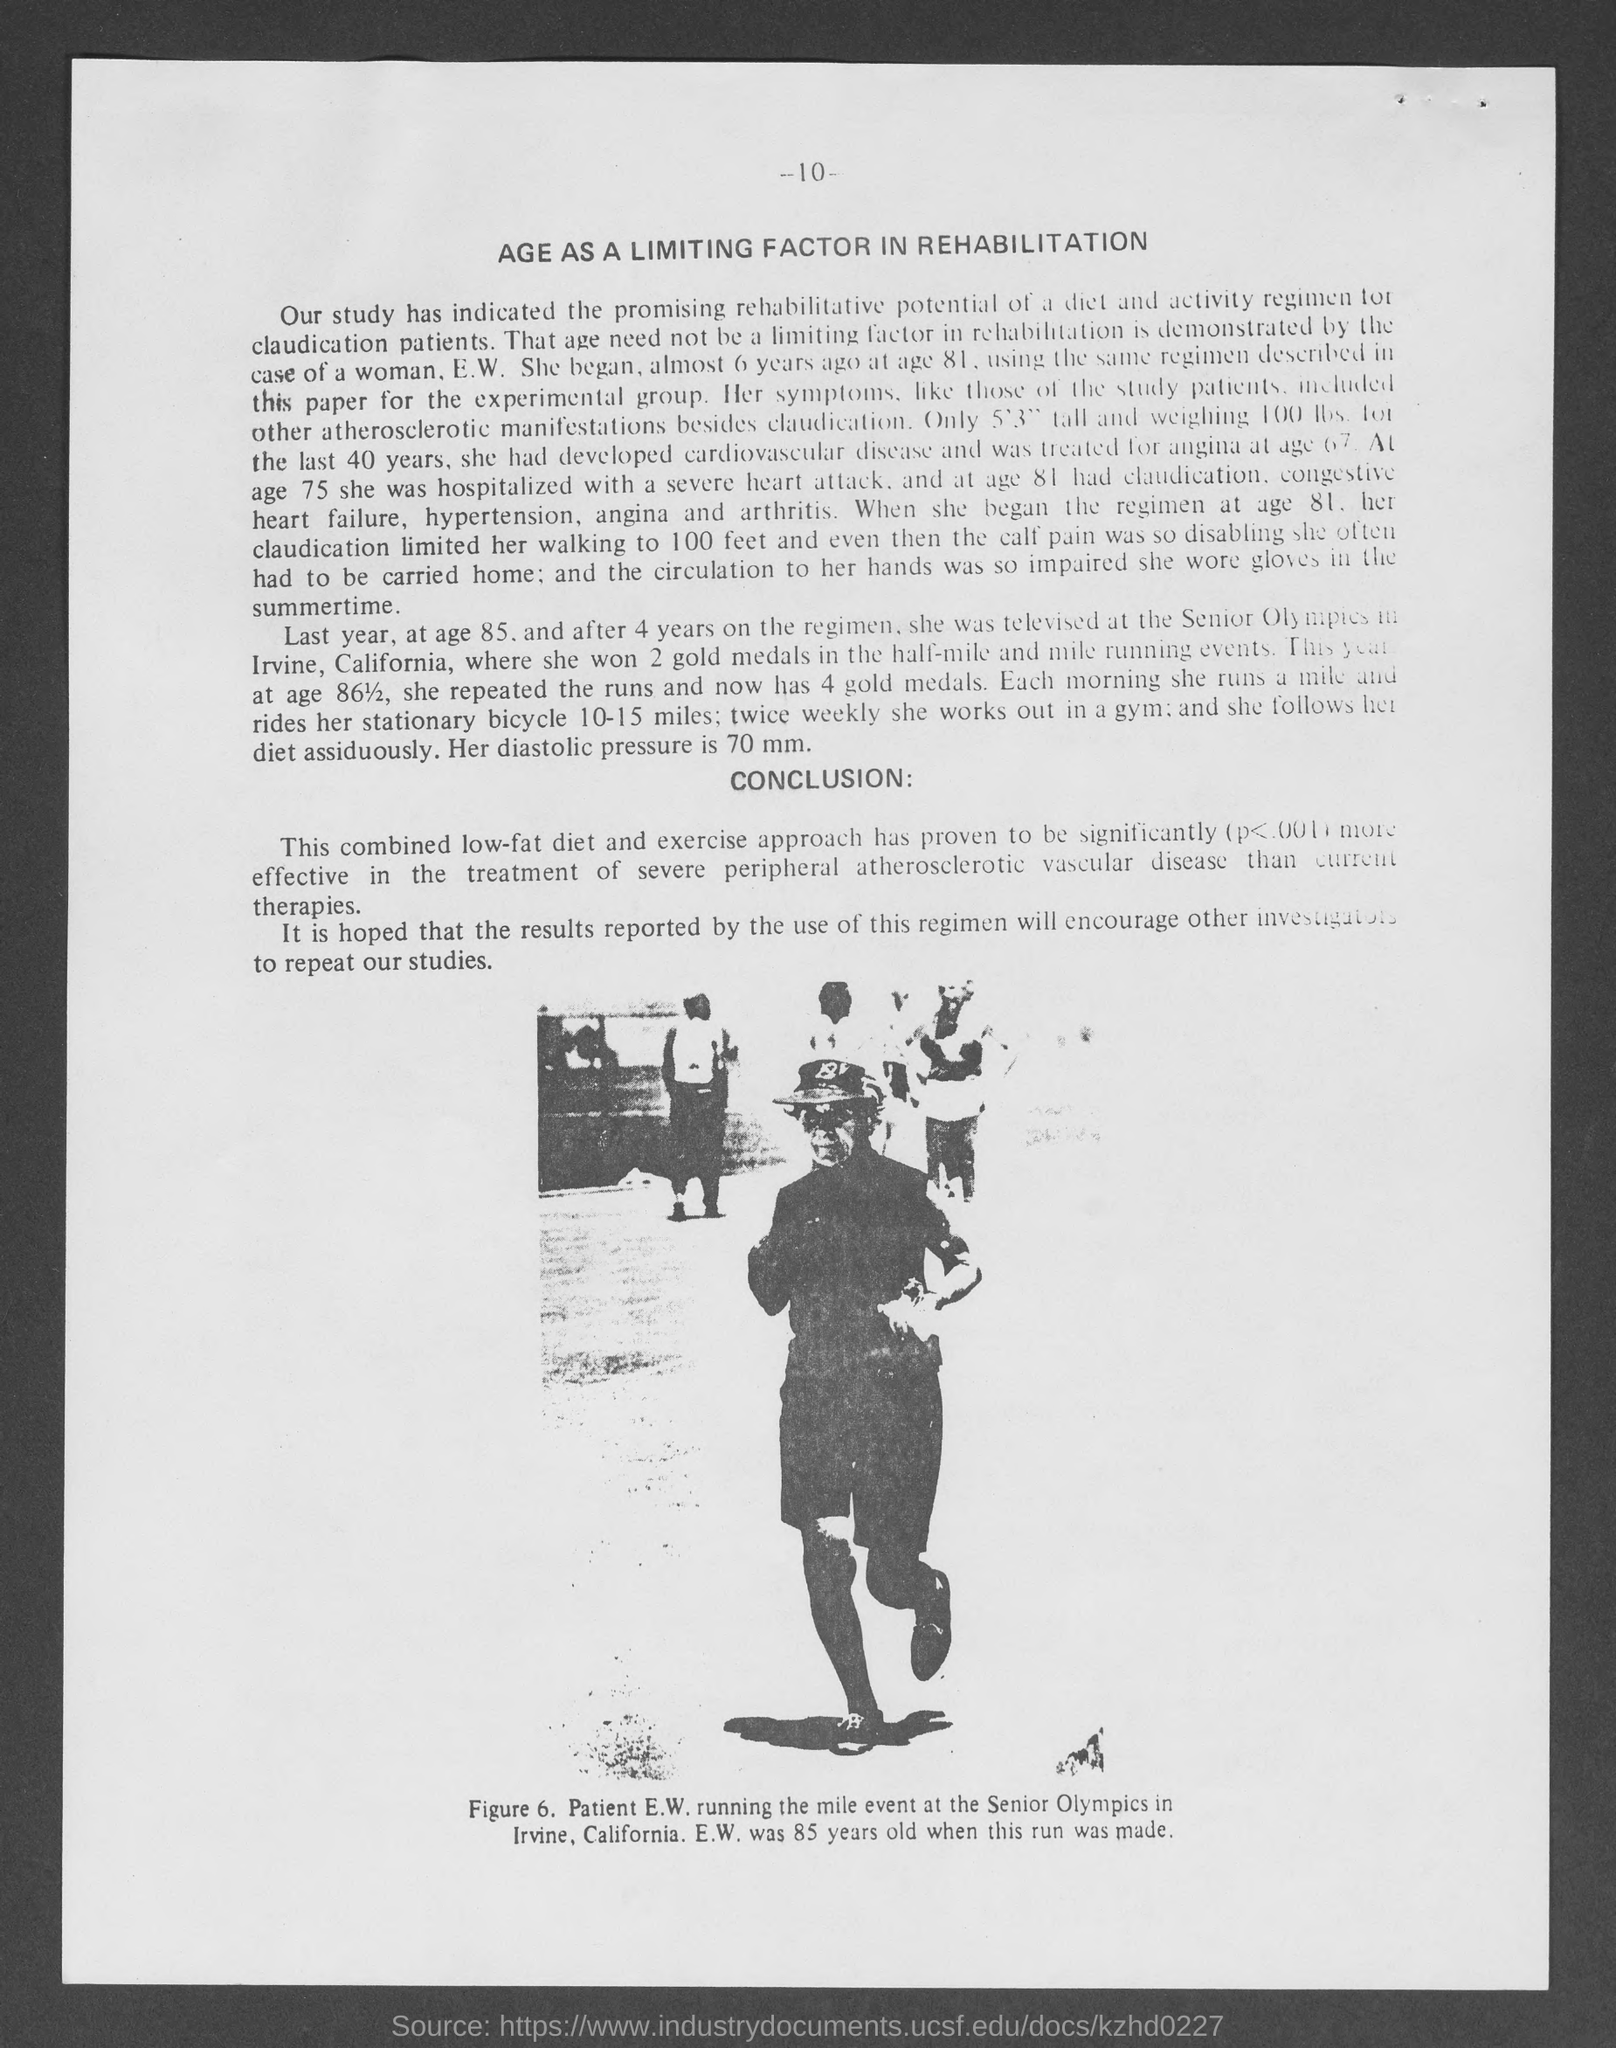Whose picture is shown?
Ensure brevity in your answer.  PATIENT E.W. What is the page number given at the top of the page?
Ensure brevity in your answer.  -10-. Mention the heading of the document?
Ensure brevity in your answer.  AGE AS A LIMITING FACTOR IN REHABILITATION. In figure 6. "patient e.w" is "running the mile event" at which competition?
Provide a succinct answer. SENIOR OLYMPICS. Where was "Senior Olympics" held?
Offer a very short reply. IRVINE, CALIFORNIA. How many gold medals did she won at age 85?
Give a very brief answer. 2. "Combined low-fat diet and exercise approach has proven to be significantly effective in the treatment of" which disease?
Keep it short and to the point. SEVERE PERIPHERAL ATHEROSCLEROTIC VASCULAR DISEASE. 